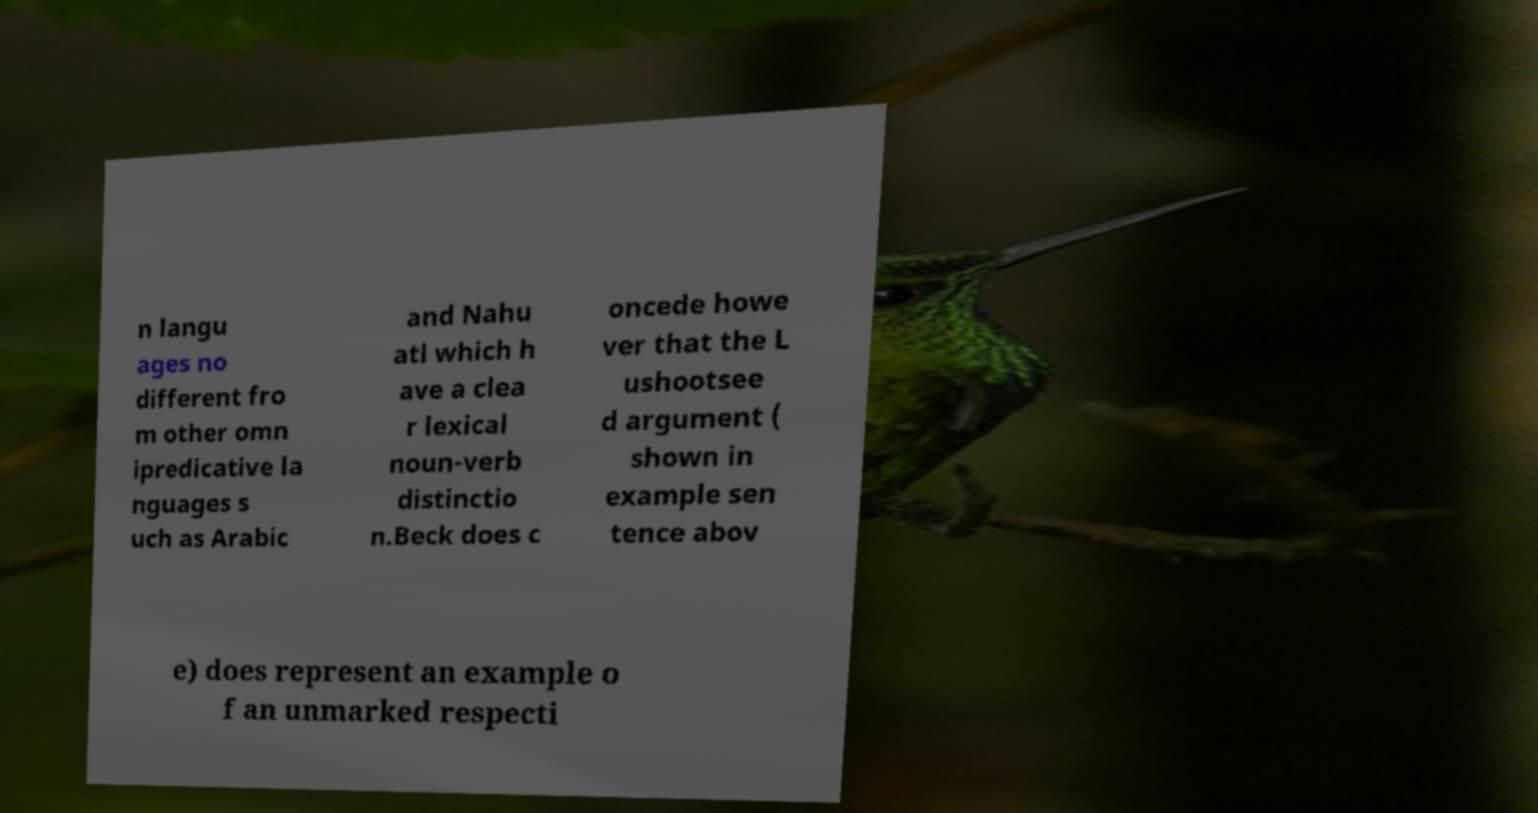There's text embedded in this image that I need extracted. Can you transcribe it verbatim? n langu ages no different fro m other omn ipredicative la nguages s uch as Arabic and Nahu atl which h ave a clea r lexical noun-verb distinctio n.Beck does c oncede howe ver that the L ushootsee d argument ( shown in example sen tence abov e) does represent an example o f an unmarked respecti 